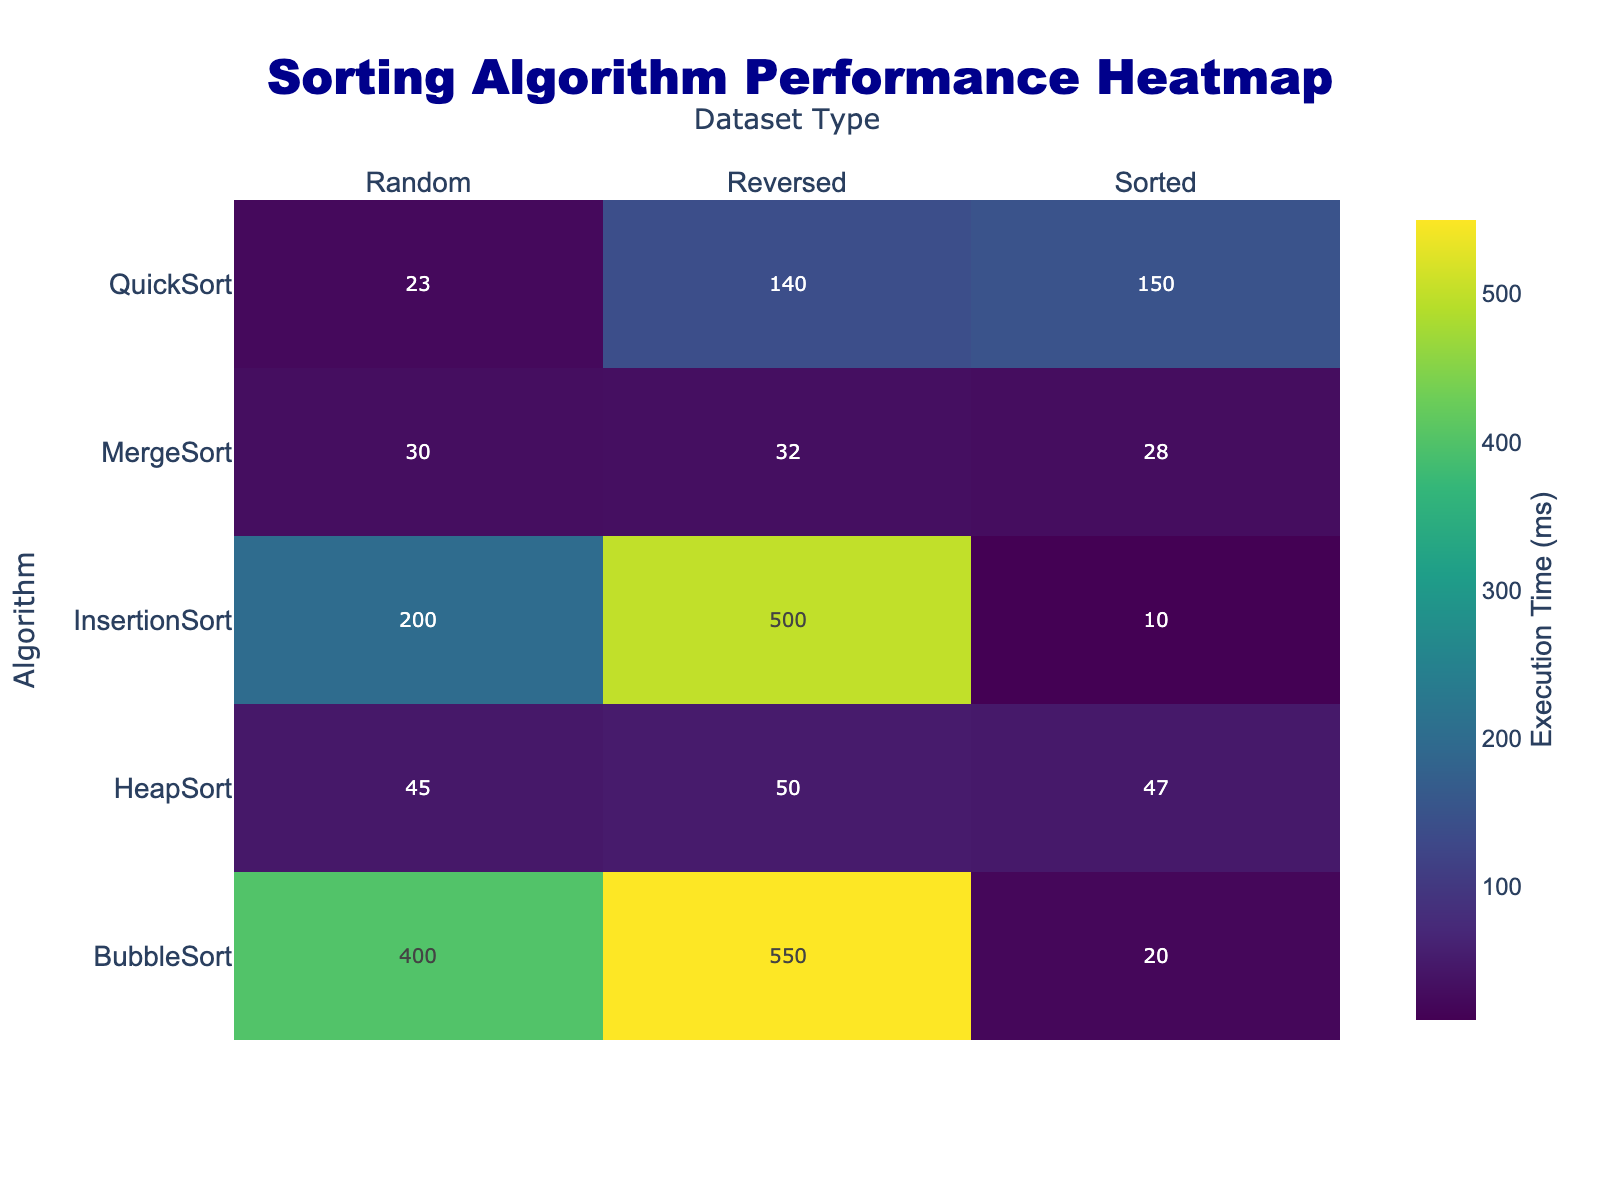What's the title of the heatmap? The title of the heatmap is displayed at the top of the plot.
Answer: Sorting Algorithm Performance Heatmap What is the execution time of MergeSort on a reversed dataset? Locate the cell corresponding to MergeSort and the column for the Reversed dataset. The value in this cell shows the execution time in milliseconds.
Answer: 32 ms Which sorting algorithm performs the worst on a reversed dataset? Compare the execution times of all algorithms on the Reversed dataset and identify the highest value.
Answer: BubbleSort How does the performance of QuickSort on a sorted dataset compare to its performance on a random dataset? Check QuickSort's execution time for Sorted and Random datasets. Compare the times to determine the difference.
Answer: QuickSort performs significantly worse on Sorted datasets than on Random datasets What is the average execution time of QuickSort across all dataset types? Sum the execution times of QuickSort for all dataset types and divide by the number of types (3 in this case).
Answer: (23 + 150 + 140) / 3 = 104.33 ms Which algorithm shows the least variation in performance across different dataset types? Calculate or observe the range of execution times (difference between max and min) for each algorithm. The one with the smallest range has the least variation.
Answer: MergeSort Which algorithm performs best on a sorted dataset? Check the execution times for all algorithms on the Sorted dataset and identify the lowest value.
Answer: InsertionSort Are there any algorithms that have a consistent performance (good) across all dataset types? Identify algorithms with the same or similar execution times across Random, Sorted, and Reversed datasets.
Answer: MergeSort and HeapSort What is the difference in execution time between the best and worst performing algorithms on a random dataset? Identify the execution times of the best and worst performing algorithms on a Random dataset, and find the difference between these times.
Answer: 400 ms (BubbleSort) - 23 ms (QuickSort) = 377 ms 